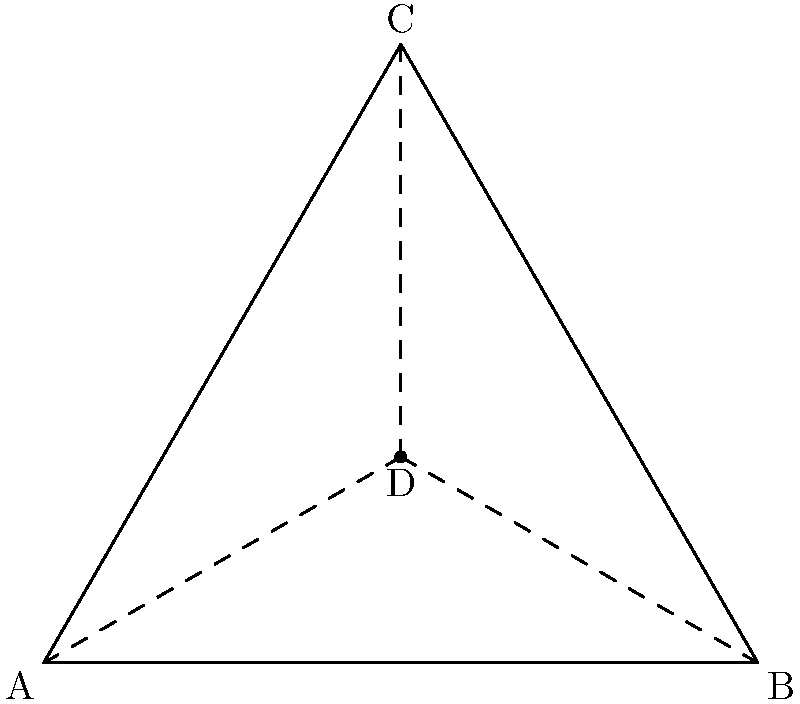In a hyperbolic plane representing a strategic military formation, triangle ABC represents the positions of three allied units. Point D is a critical defensive position. If the hyperbolic distance from D to each vertex is equal, and the sum of the angles in triangle ABC is 150°, what is the measure of angle ADB in degrees? How might this formation advantage our forces against potential Russian aggression? Let's approach this step-by-step:

1) In Euclidean geometry, the sum of angles in a triangle is always 180°. However, in hyperbolic geometry, this sum is always less than 180°.

2) Given that the sum of angles in triangle ABC is 150°, we can calculate the defect:
   $$ \text{Defect} = 180° - 150° = 30° $$

3) In hyperbolic geometry, the area of a triangle is proportional to its defect. The larger the defect, the larger the triangle.

4) Point D is equidistant from A, B, and C. This means D is the center of the hyperbolic circle passing through A, B, and C.

5) In hyperbolic geometry, the perpendicular bisectors of the sides of a triangle always meet at a single point, which is the center of the circumscribed circle.

6) Therefore, AD, BD, and CD are the perpendicular bisectors of the sides of triangle ABC.

7) In hyperbolic geometry, perpendicular lines behave similarly to Euclidean geometry. The angle between a line and a perpendicular bisector is always 90°.

8) Thus, angle ADB is a right angle in hyperbolic geometry, just as it would be in Euclidean geometry.

9) Therefore, the measure of angle ADB is 90°.

This formation provides a strategic advantage against potential Russian aggression by:
- Maximizing coverage area while maintaining equal response times from the central point D.
- Allowing for rapid redeployment along the hyperbolic lines, which represent the shortest paths in this geometry.
- Confusing enemy forces who might be using traditional Euclidean-based strategies.
Answer: 90° 